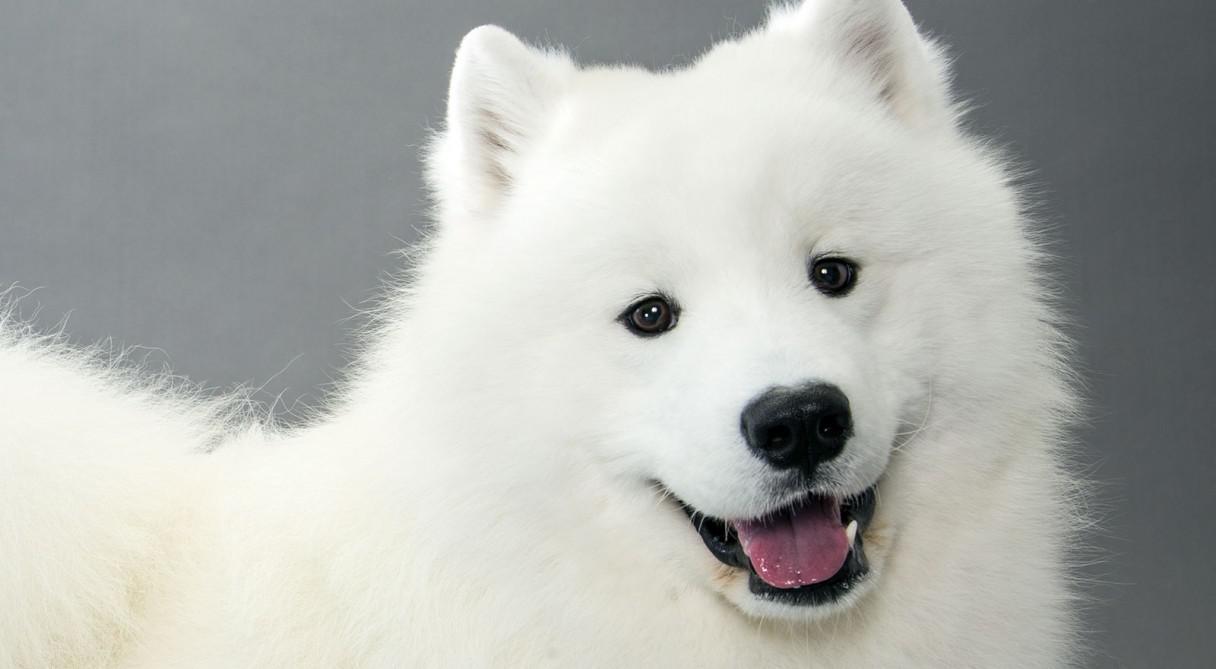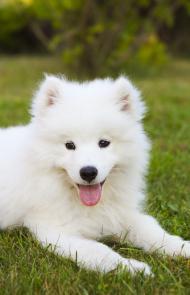The first image is the image on the left, the second image is the image on the right. Given the left and right images, does the statement "At least one of the images shows a dog sitting." hold true? Answer yes or no. No. The first image is the image on the left, the second image is the image on the right. Examine the images to the left and right. Is the description "All white dogs are sitting in green grass." accurate? Answer yes or no. No. 